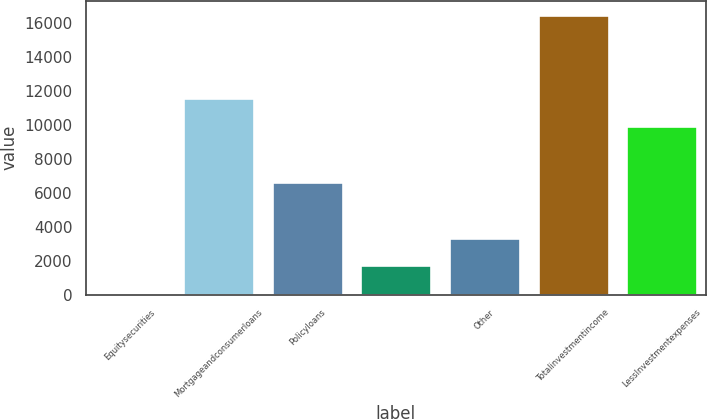Convert chart. <chart><loc_0><loc_0><loc_500><loc_500><bar_chart><fcel>Equitysecurities<fcel>Mortgageandconsumerloans<fcel>Policyloans<fcel>Unnamed: 3<fcel>Other<fcel>Totalinvestmentincome<fcel>LessInvestmentexpenses<nl><fcel>79<fcel>11561.8<fcel>6640.6<fcel>1719.4<fcel>3359.8<fcel>16483<fcel>9921.4<nl></chart> 